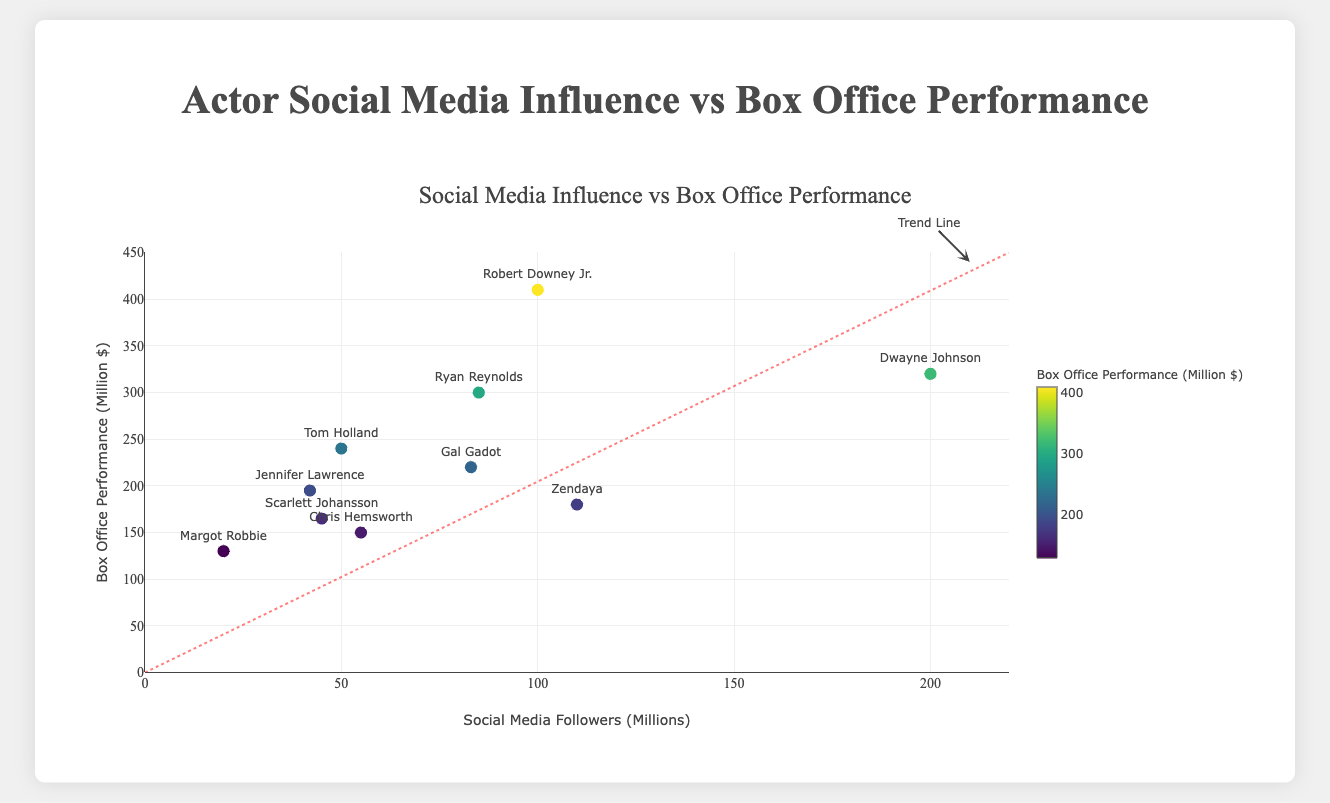What's the title of the chart? The title of the chart is located at the top of the chart and is clearly written in a large, bold font.
Answer: Actor Social Media Influence vs Box Office Performance What is the y-axis representing? The label on the y-axis indicates what is being measured up the vertical side of the chart. In this case, it represents the "Box Office Performance (Million $)".
Answer: Box Office Performance (Million $) Which actor has the highest number of social media followers? By looking at the x-axis values and identifying the point that is furthest to the right, we see that Dwayne Johnson has the highest number of social media followers, marked at 200 million.
Answer: Dwayne Johnson What box office performance does Scarlett Johansson have according to the chart? Locate Scarlett Johansson on the chart by finding her label near the markers, then check the y-axis value of her corresponding marker.
Answer: $165 million How many actors have social media followers between 50 and 100 million? Count the number of data points on the x-axis that fall between the values of 50 and 100 million. These include Chris Hemsworth, Robert Downey Jr., Gal Gadot, Ryan Reynolds, and Tom Holland.
Answer: 5 Which actor has the lowest box office performance, and what is its value? Locate the actor with the lowest point on the y-axis, which is Margot Robbie, and note the corresponding y-coordinate value.
Answer: Margot Robbie, $130 million Compare the box office performance of Zendaya and Tom Holland. Who performed better and by how much? Find Zendaya and Tom Holland on the chart. Zendaya's box office performance is $180 million, and Tom Holland's is $240 million. The difference is calculated as $240M - $180M = $60M.
Answer: Tom Holland, $60 million What is the average social media followers of all actors shown? Add all social media followers together (200 + 55 + 45 + 100 + 83 + 110 + 85 + 50 + 42 + 20 = 790 million) then divide by the number of actors (10). The average is 790/10 = 79 million.
Answer: 79 million Is there an obvious correlation between social media followers and box office performance? Look at the general trend of the data points. If they appear to rise together along the red trend line, there is a positive correlation. The scatter plot trend line shows a positive correlation.
Answer: Yes How does the trend line help interpret the relationship between social media followers and box office performance? The trend line, which is a diagonal line from bottom left to upper right, suggests that as the number of social media followers increases, the box office performance also tends to increase.
Answer: Shows the positive correlation 